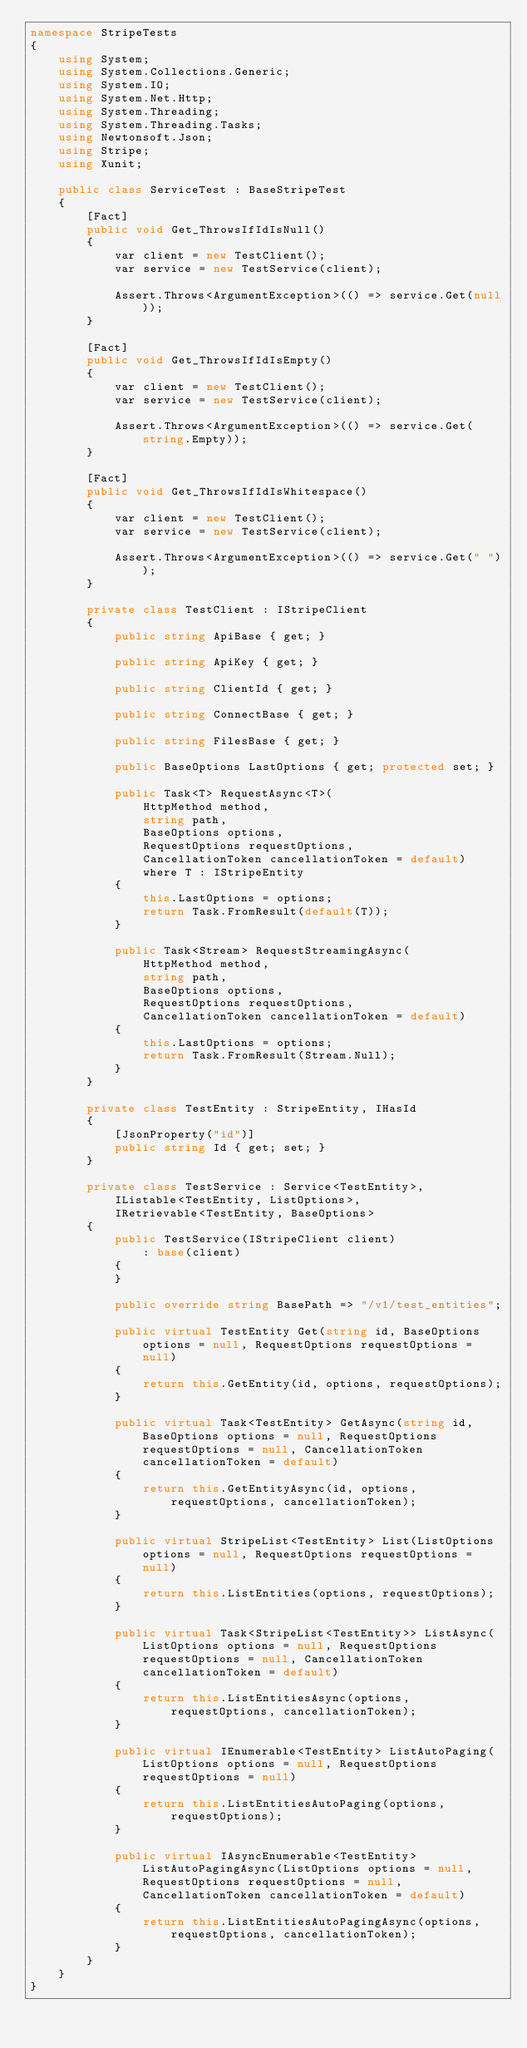<code> <loc_0><loc_0><loc_500><loc_500><_C#_>namespace StripeTests
{
    using System;
    using System.Collections.Generic;
    using System.IO;
    using System.Net.Http;
    using System.Threading;
    using System.Threading.Tasks;
    using Newtonsoft.Json;
    using Stripe;
    using Xunit;

    public class ServiceTest : BaseStripeTest
    {
        [Fact]
        public void Get_ThrowsIfIdIsNull()
        {
            var client = new TestClient();
            var service = new TestService(client);

            Assert.Throws<ArgumentException>(() => service.Get(null));
        }

        [Fact]
        public void Get_ThrowsIfIdIsEmpty()
        {
            var client = new TestClient();
            var service = new TestService(client);

            Assert.Throws<ArgumentException>(() => service.Get(string.Empty));
        }

        [Fact]
        public void Get_ThrowsIfIdIsWhitespace()
        {
            var client = new TestClient();
            var service = new TestService(client);

            Assert.Throws<ArgumentException>(() => service.Get(" "));
        }

        private class TestClient : IStripeClient
        {
            public string ApiBase { get; }

            public string ApiKey { get; }

            public string ClientId { get; }

            public string ConnectBase { get; }

            public string FilesBase { get; }

            public BaseOptions LastOptions { get; protected set; }

            public Task<T> RequestAsync<T>(
                HttpMethod method,
                string path,
                BaseOptions options,
                RequestOptions requestOptions,
                CancellationToken cancellationToken = default)
                where T : IStripeEntity
            {
                this.LastOptions = options;
                return Task.FromResult(default(T));
            }

            public Task<Stream> RequestStreamingAsync(
                HttpMethod method,
                string path,
                BaseOptions options,
                RequestOptions requestOptions,
                CancellationToken cancellationToken = default)
            {
                this.LastOptions = options;
                return Task.FromResult(Stream.Null);
            }
        }

        private class TestEntity : StripeEntity, IHasId
        {
            [JsonProperty("id")]
            public string Id { get; set; }
        }

        private class TestService : Service<TestEntity>,
            IListable<TestEntity, ListOptions>,
            IRetrievable<TestEntity, BaseOptions>
        {
            public TestService(IStripeClient client)
                : base(client)
            {
            }

            public override string BasePath => "/v1/test_entities";

            public virtual TestEntity Get(string id, BaseOptions options = null, RequestOptions requestOptions = null)
            {
                return this.GetEntity(id, options, requestOptions);
            }

            public virtual Task<TestEntity> GetAsync(string id, BaseOptions options = null, RequestOptions requestOptions = null, CancellationToken cancellationToken = default)
            {
                return this.GetEntityAsync(id, options, requestOptions, cancellationToken);
            }

            public virtual StripeList<TestEntity> List(ListOptions options = null, RequestOptions requestOptions = null)
            {
                return this.ListEntities(options, requestOptions);
            }

            public virtual Task<StripeList<TestEntity>> ListAsync(ListOptions options = null, RequestOptions requestOptions = null, CancellationToken cancellationToken = default)
            {
                return this.ListEntitiesAsync(options, requestOptions, cancellationToken);
            }

            public virtual IEnumerable<TestEntity> ListAutoPaging(ListOptions options = null, RequestOptions requestOptions = null)
            {
                return this.ListEntitiesAutoPaging(options, requestOptions);
            }

            public virtual IAsyncEnumerable<TestEntity> ListAutoPagingAsync(ListOptions options = null, RequestOptions requestOptions = null, CancellationToken cancellationToken = default)
            {
                return this.ListEntitiesAutoPagingAsync(options, requestOptions, cancellationToken);
            }
        }
    }
}
</code> 